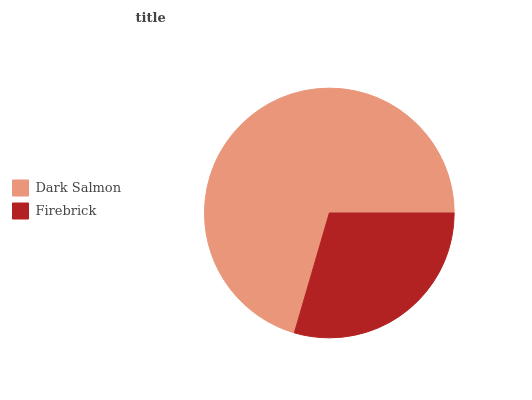Is Firebrick the minimum?
Answer yes or no. Yes. Is Dark Salmon the maximum?
Answer yes or no. Yes. Is Firebrick the maximum?
Answer yes or no. No. Is Dark Salmon greater than Firebrick?
Answer yes or no. Yes. Is Firebrick less than Dark Salmon?
Answer yes or no. Yes. Is Firebrick greater than Dark Salmon?
Answer yes or no. No. Is Dark Salmon less than Firebrick?
Answer yes or no. No. Is Dark Salmon the high median?
Answer yes or no. Yes. Is Firebrick the low median?
Answer yes or no. Yes. Is Firebrick the high median?
Answer yes or no. No. Is Dark Salmon the low median?
Answer yes or no. No. 